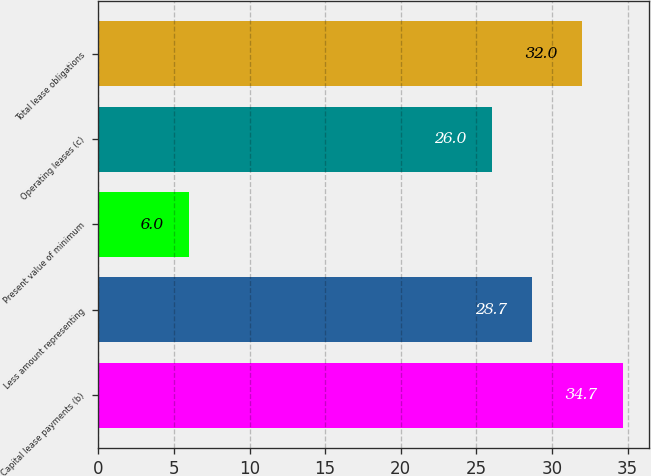Convert chart. <chart><loc_0><loc_0><loc_500><loc_500><bar_chart><fcel>Capital lease payments (b)<fcel>Less amount representing<fcel>Present value of minimum<fcel>Operating leases (c)<fcel>Total lease obligations<nl><fcel>34.7<fcel>28.7<fcel>6<fcel>26<fcel>32<nl></chart> 